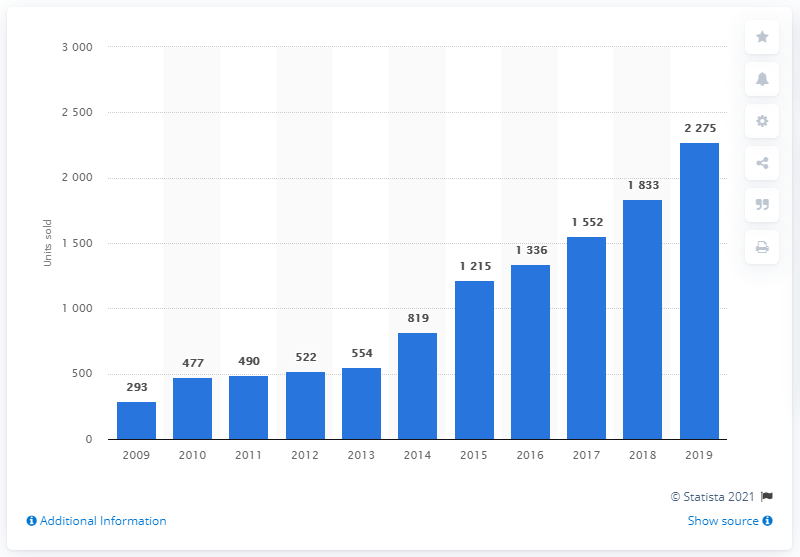Specify some key components in this picture. In 2009, a total of 293 Porsche cars were sold in Sweden. 